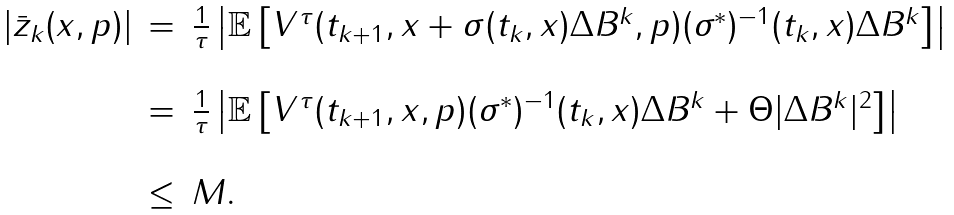<formula> <loc_0><loc_0><loc_500><loc_500>\begin{array} { r c l } | \bar { z } _ { k } ( x , p ) | & = & \frac { 1 } { \tau } \left | \mathbb { E } \left [ V ^ { \tau } ( t _ { k + 1 } , x + \sigma ( t _ { k } , x ) \Delta B ^ { k } , p ) ( \sigma ^ { * } ) ^ { - 1 } ( t _ { k } , x ) \Delta B ^ { k } \right ] \right | \\ \ \\ & = & \frac { 1 } { \tau } \left | \mathbb { E } \left [ V ^ { \tau } ( t _ { k + 1 } , x , p ) ( \sigma ^ { * } ) ^ { - 1 } ( t _ { k } , x ) \Delta B ^ { k } + \Theta | \Delta B ^ { k } | ^ { 2 } \right ] \right | \\ \ \\ & \leq & M . \end{array}</formula> 